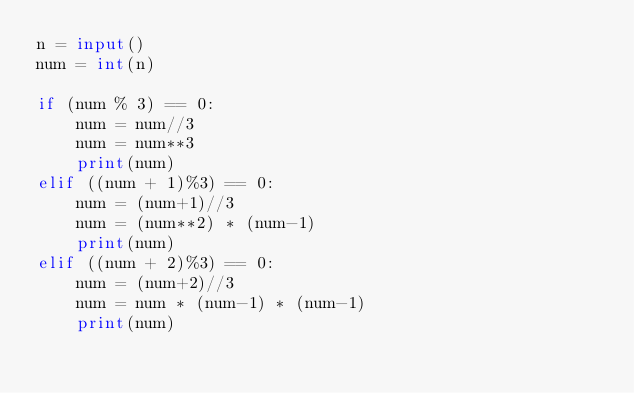<code> <loc_0><loc_0><loc_500><loc_500><_Python_>n = input()
num = int(n)

if (num % 3) == 0:
	num = num//3
	num = num**3
	print(num)
elif ((num + 1)%3) == 0:
    num = (num+1)//3
    num = (num**2) * (num-1)
    print(num)
elif ((num + 2)%3) == 0:
    num = (num+2)//3
    num = num * (num-1) * (num-1)
    print(num)
  	</code> 